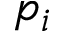<formula> <loc_0><loc_0><loc_500><loc_500>p _ { i }</formula> 